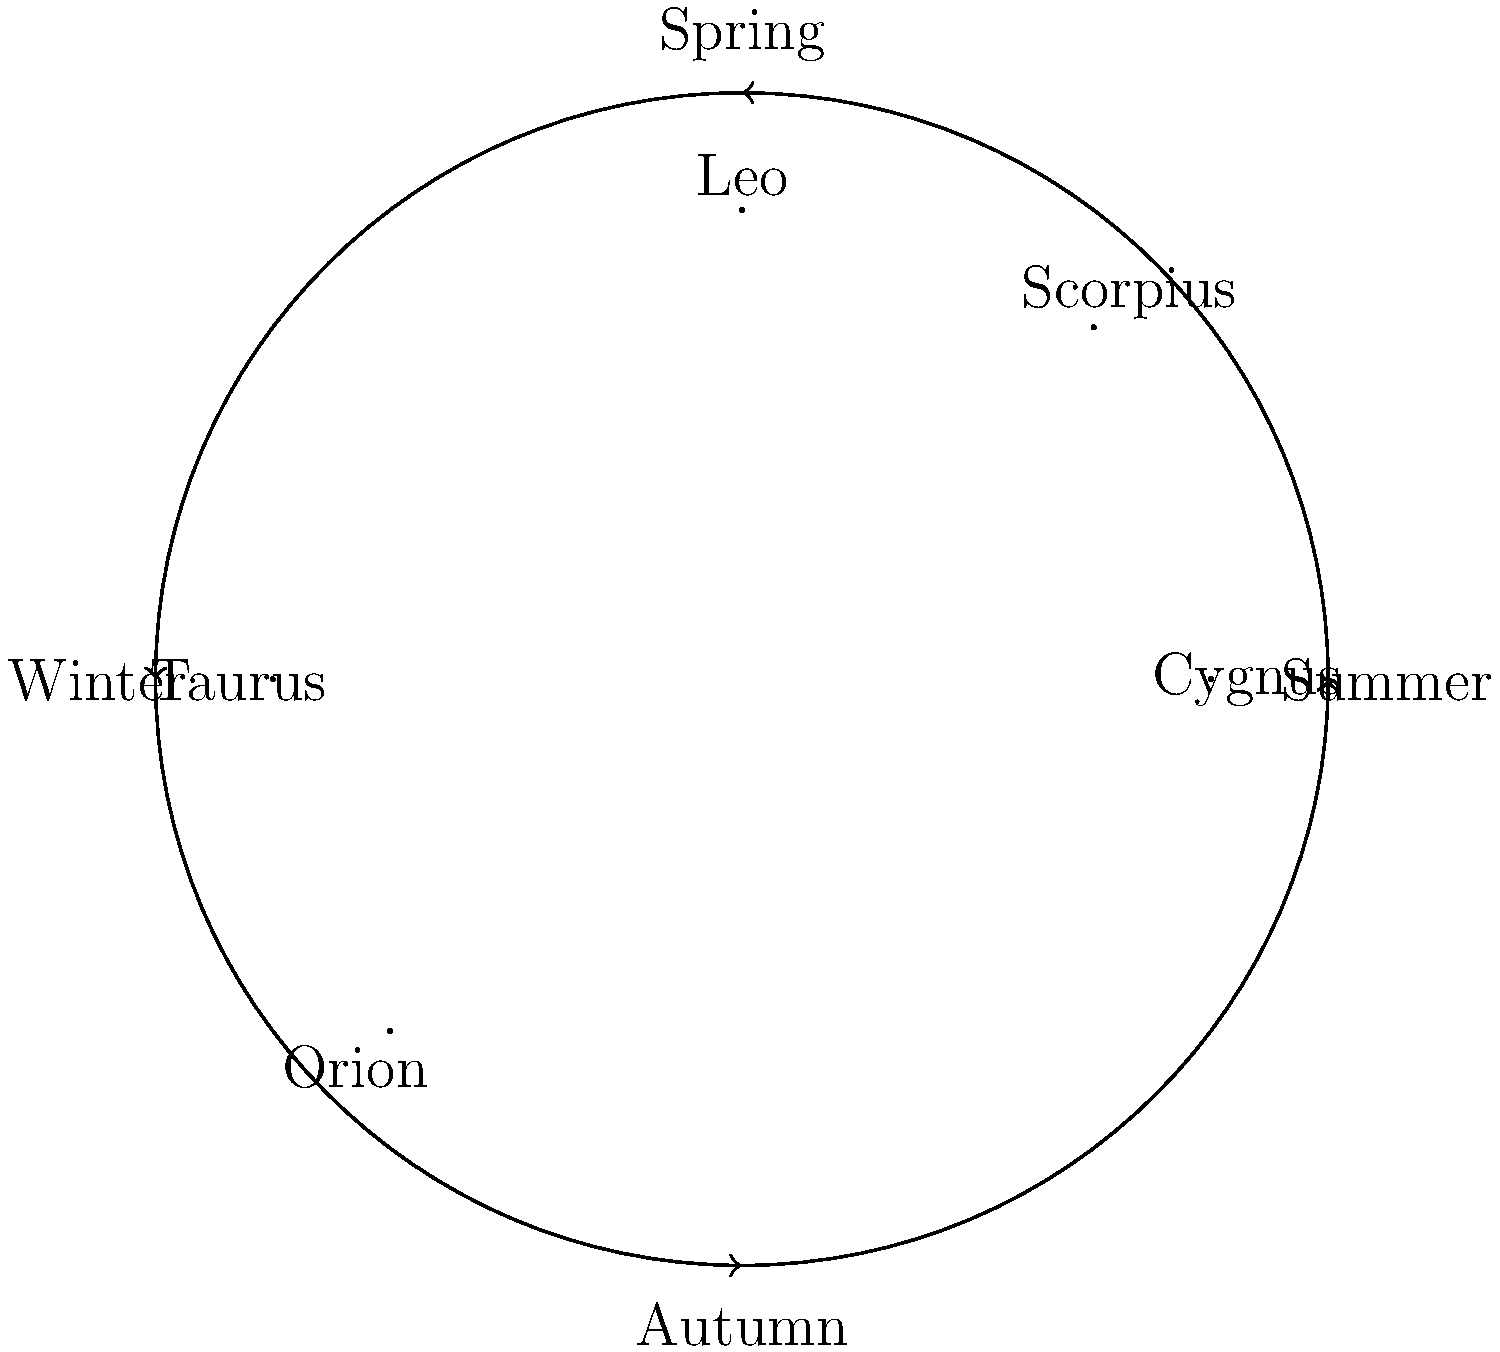As an indie musician who uses recycled materials for album art, you're designing a series of seasonal album covers featuring constellations. Which constellation would be most appropriate for your winter-themed album based on its visibility during that season? To determine the most appropriate constellation for a winter-themed album, we need to consider the visibility of constellations during different seasons:

1. The diagram shows the night sky divided into four seasons: Spring, Summer, Autumn, and Winter.

2. Each season has specific constellations that are prominently visible during that time:
   - Spring: Leo
   - Summer: Scorpius
   - Autumn: Cygnus
   - Winter: Orion and Taurus

3. For a winter-themed album, we should focus on constellations visible during winter.

4. In the diagram, we can see that Orion and Taurus are positioned in the winter quadrant.

5. Between these two, Orion is one of the most recognizable and iconic winter constellations, making it an excellent choice for a winter-themed album cover.

6. Orion is known for its distinctive "belt" of three stars and is easily identifiable, which could make for a striking and memorable album cover design using recycled materials.

Therefore, Orion would be the most appropriate constellation for a winter-themed album based on its visibility during that season.
Answer: Orion 